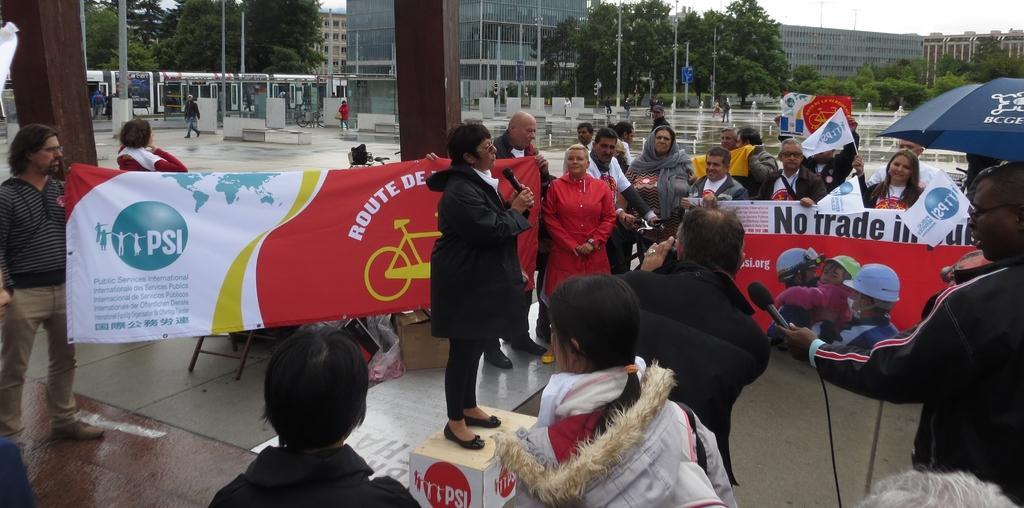Describe this image in one or two sentences. In the image I can see a person standing on the box and speaking in a microphone, around her there are so many other people standing in which some of them holding banners, at the back there is a building and trees and some electrical poles. 